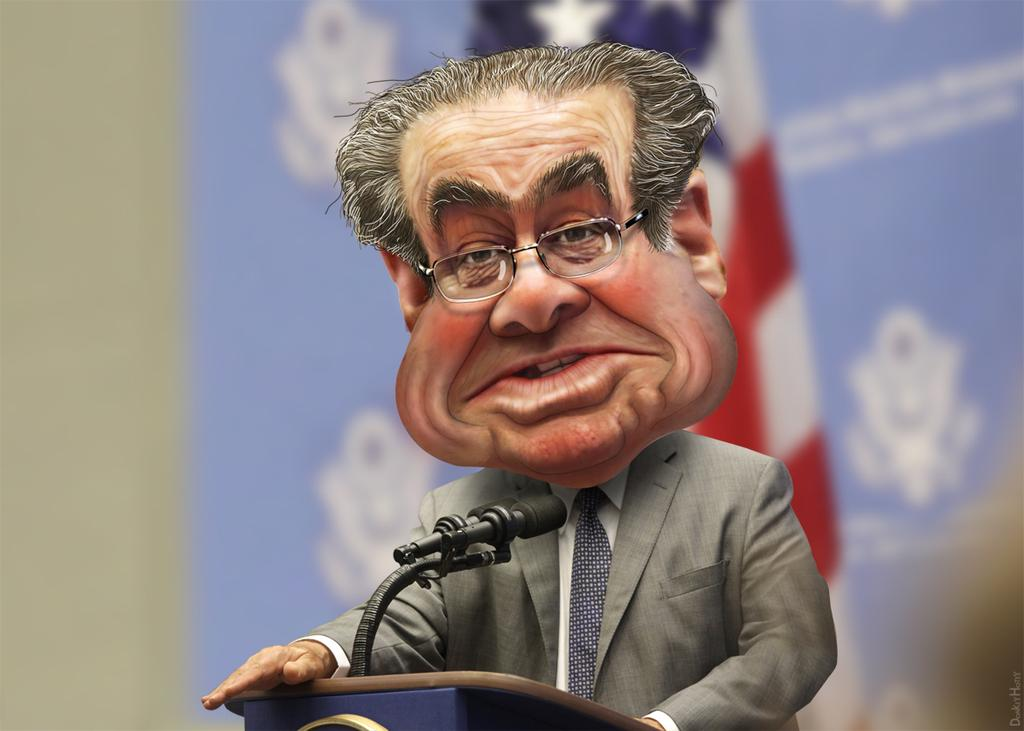What is the person in the image doing? The person is standing near a podium. What can be seen in the background of the image? There is a flag, a banner, and a wall in the background. What type of impulse can be seen affecting the box in the image? There is no box present in the image, and therefore no impulse affecting it. 